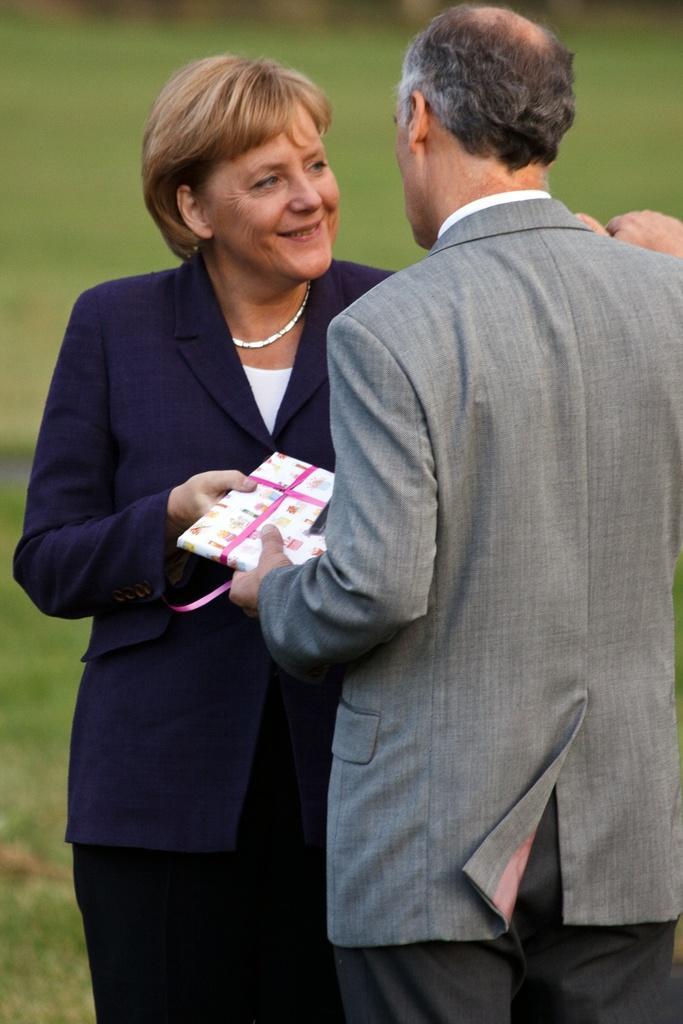Describe this image in one or two sentences. In this image, we can see women and men are holding a gift pack. Here we can see woman is smiling. Background there is a blur view. 